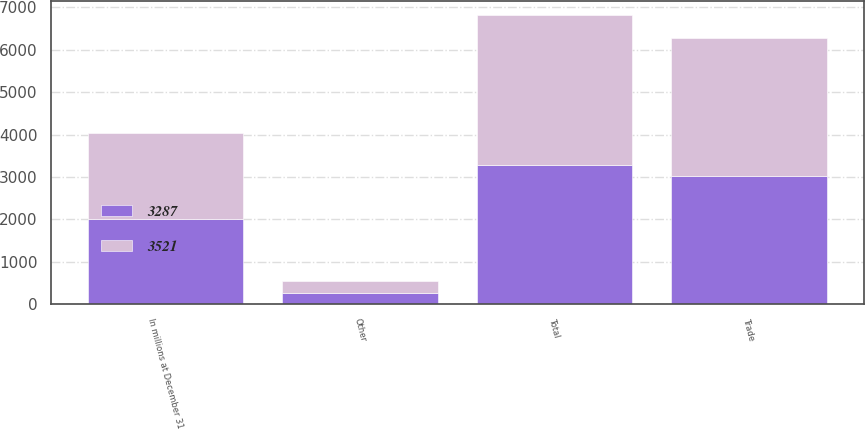<chart> <loc_0><loc_0><loc_500><loc_500><stacked_bar_chart><ecel><fcel>In millions at December 31<fcel>Trade<fcel>Other<fcel>Total<nl><fcel>3521<fcel>2018<fcel>3249<fcel>272<fcel>3521<nl><fcel>3287<fcel>2017<fcel>3017<fcel>270<fcel>3287<nl></chart> 